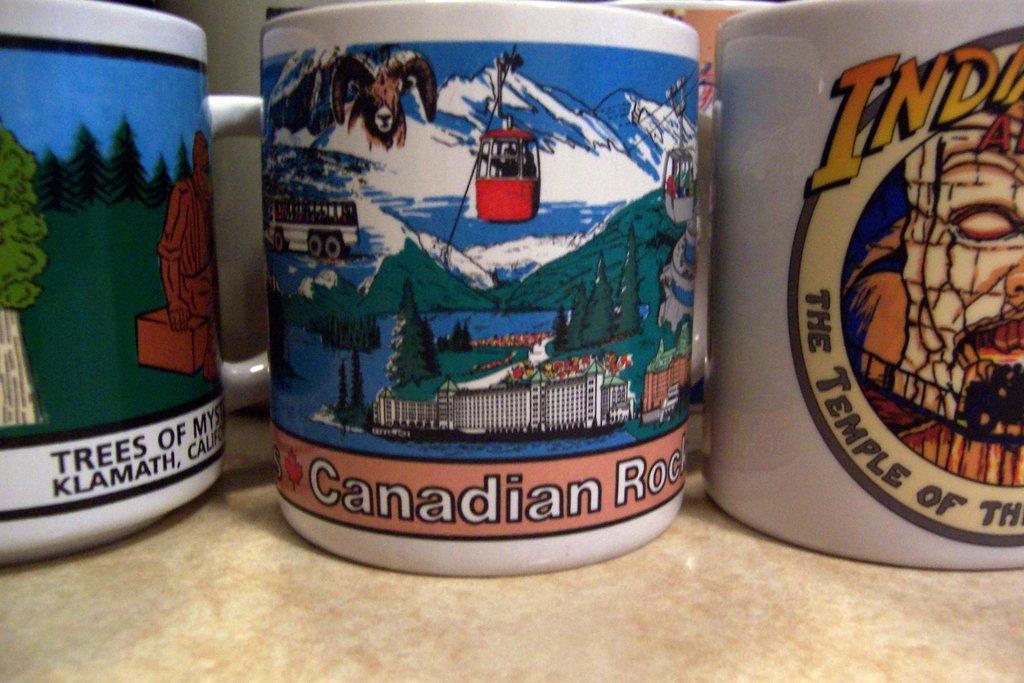How many cups can be seen in the image? There are three cups in the image. Where are the cups located? The cups are placed on a table. Are there any other cups visible in the image? Yes, there are two additional cups visible in the background of the image. What type of car is parked next to the table in the image? There is no car present in the image; it only features cups on a table. 